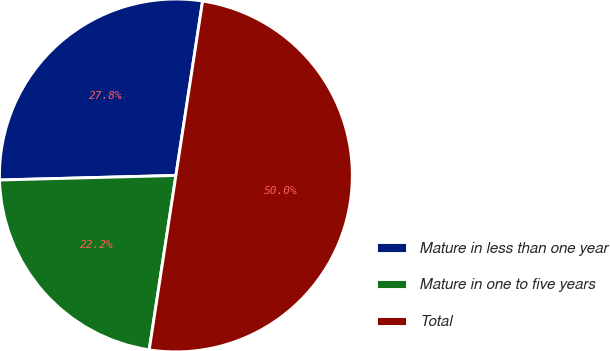<chart> <loc_0><loc_0><loc_500><loc_500><pie_chart><fcel>Mature in less than one year<fcel>Mature in one to five years<fcel>Total<nl><fcel>27.83%<fcel>22.17%<fcel>50.0%<nl></chart> 